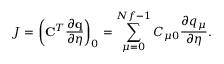<formula> <loc_0><loc_0><loc_500><loc_500>J = \left ( C ^ { T } \frac { \partial q } { \partial \eta } \right ) _ { 0 } = \sum _ { \mu = 0 } ^ { N f - 1 } C _ { \mu 0 } \frac { \partial q _ { \mu } } { \partial \eta } .</formula> 